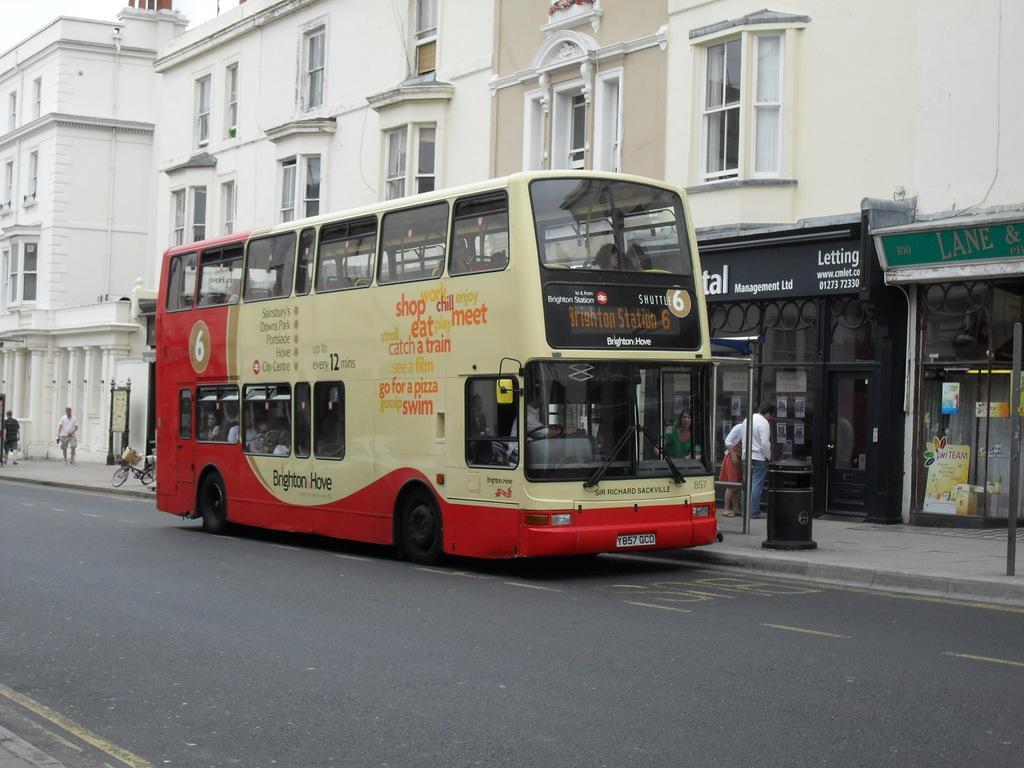Please provide a concise description of this image. This image is clicked on the road. There is a bus on the road. There is text on the bus. There are people sitting inside the bus. Behind the bus there is a walkway. There are people walking on the walkway. Beside the bus there is a dustbin on the walkway. Behind the bus there is a cycle parked on the walkway. Beside the walkway there are buildings. To the right there are boards with text on the buildings. There are glass walls to the buildings. In the top left there is the sky. 